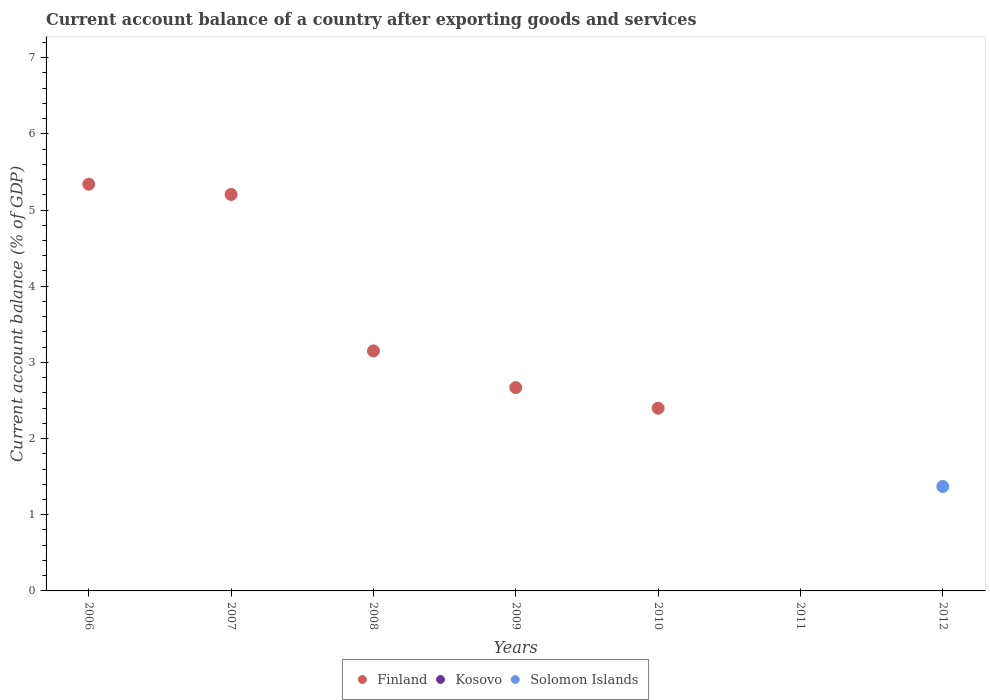Is the number of dotlines equal to the number of legend labels?
Your response must be concise. No. What is the account balance in Finland in 2008?
Your answer should be compact. 3.15. Across all years, what is the maximum account balance in Finland?
Your response must be concise. 5.34. What is the total account balance in Kosovo in the graph?
Offer a terse response. 0. What is the difference between the account balance in Finland in 2008 and that in 2010?
Ensure brevity in your answer.  0.75. What is the average account balance in Solomon Islands per year?
Your response must be concise. 0.2. In how many years, is the account balance in Finland greater than 2 %?
Ensure brevity in your answer.  5. What is the ratio of the account balance in Finland in 2006 to that in 2008?
Offer a terse response. 1.69. What is the difference between the highest and the second highest account balance in Finland?
Ensure brevity in your answer.  0.13. What is the difference between the highest and the lowest account balance in Solomon Islands?
Offer a very short reply. 1.37. In how many years, is the account balance in Kosovo greater than the average account balance in Kosovo taken over all years?
Provide a short and direct response. 0. Is it the case that in every year, the sum of the account balance in Kosovo and account balance in Finland  is greater than the account balance in Solomon Islands?
Make the answer very short. No. Is the account balance in Kosovo strictly greater than the account balance in Solomon Islands over the years?
Offer a terse response. No. Is the account balance in Solomon Islands strictly less than the account balance in Finland over the years?
Your answer should be compact. No. How many years are there in the graph?
Keep it short and to the point. 7. Where does the legend appear in the graph?
Ensure brevity in your answer.  Bottom center. How many legend labels are there?
Ensure brevity in your answer.  3. What is the title of the graph?
Keep it short and to the point. Current account balance of a country after exporting goods and services. Does "Mexico" appear as one of the legend labels in the graph?
Your answer should be very brief. No. What is the label or title of the X-axis?
Offer a very short reply. Years. What is the label or title of the Y-axis?
Your answer should be compact. Current account balance (% of GDP). What is the Current account balance (% of GDP) in Finland in 2006?
Keep it short and to the point. 5.34. What is the Current account balance (% of GDP) in Kosovo in 2006?
Offer a very short reply. 0. What is the Current account balance (% of GDP) in Solomon Islands in 2006?
Your answer should be very brief. 0. What is the Current account balance (% of GDP) in Finland in 2007?
Provide a succinct answer. 5.2. What is the Current account balance (% of GDP) in Solomon Islands in 2007?
Your response must be concise. 0. What is the Current account balance (% of GDP) of Finland in 2008?
Your answer should be compact. 3.15. What is the Current account balance (% of GDP) of Solomon Islands in 2008?
Offer a terse response. 0. What is the Current account balance (% of GDP) of Finland in 2009?
Offer a very short reply. 2.67. What is the Current account balance (% of GDP) of Kosovo in 2009?
Ensure brevity in your answer.  0. What is the Current account balance (% of GDP) of Finland in 2010?
Ensure brevity in your answer.  2.4. What is the Current account balance (% of GDP) in Kosovo in 2010?
Give a very brief answer. 0. What is the Current account balance (% of GDP) in Solomon Islands in 2010?
Offer a very short reply. 0. What is the Current account balance (% of GDP) in Solomon Islands in 2011?
Offer a terse response. 0. What is the Current account balance (% of GDP) in Finland in 2012?
Make the answer very short. 0. What is the Current account balance (% of GDP) of Kosovo in 2012?
Offer a terse response. 0. What is the Current account balance (% of GDP) of Solomon Islands in 2012?
Make the answer very short. 1.37. Across all years, what is the maximum Current account balance (% of GDP) of Finland?
Offer a very short reply. 5.34. Across all years, what is the maximum Current account balance (% of GDP) of Solomon Islands?
Make the answer very short. 1.37. What is the total Current account balance (% of GDP) in Finland in the graph?
Make the answer very short. 18.76. What is the total Current account balance (% of GDP) in Solomon Islands in the graph?
Your response must be concise. 1.37. What is the difference between the Current account balance (% of GDP) in Finland in 2006 and that in 2007?
Your response must be concise. 0.13. What is the difference between the Current account balance (% of GDP) of Finland in 2006 and that in 2008?
Offer a very short reply. 2.19. What is the difference between the Current account balance (% of GDP) in Finland in 2006 and that in 2009?
Offer a very short reply. 2.67. What is the difference between the Current account balance (% of GDP) in Finland in 2006 and that in 2010?
Give a very brief answer. 2.94. What is the difference between the Current account balance (% of GDP) of Finland in 2007 and that in 2008?
Provide a succinct answer. 2.05. What is the difference between the Current account balance (% of GDP) of Finland in 2007 and that in 2009?
Give a very brief answer. 2.54. What is the difference between the Current account balance (% of GDP) in Finland in 2007 and that in 2010?
Your response must be concise. 2.81. What is the difference between the Current account balance (% of GDP) in Finland in 2008 and that in 2009?
Keep it short and to the point. 0.48. What is the difference between the Current account balance (% of GDP) of Finland in 2008 and that in 2010?
Provide a succinct answer. 0.75. What is the difference between the Current account balance (% of GDP) in Finland in 2009 and that in 2010?
Your answer should be very brief. 0.27. What is the difference between the Current account balance (% of GDP) of Finland in 2006 and the Current account balance (% of GDP) of Solomon Islands in 2012?
Your answer should be very brief. 3.97. What is the difference between the Current account balance (% of GDP) in Finland in 2007 and the Current account balance (% of GDP) in Solomon Islands in 2012?
Your answer should be very brief. 3.83. What is the difference between the Current account balance (% of GDP) in Finland in 2008 and the Current account balance (% of GDP) in Solomon Islands in 2012?
Your answer should be very brief. 1.78. What is the difference between the Current account balance (% of GDP) in Finland in 2009 and the Current account balance (% of GDP) in Solomon Islands in 2012?
Make the answer very short. 1.3. What is the difference between the Current account balance (% of GDP) of Finland in 2010 and the Current account balance (% of GDP) of Solomon Islands in 2012?
Give a very brief answer. 1.03. What is the average Current account balance (% of GDP) of Finland per year?
Provide a short and direct response. 2.68. What is the average Current account balance (% of GDP) of Solomon Islands per year?
Keep it short and to the point. 0.2. What is the ratio of the Current account balance (% of GDP) of Finland in 2006 to that in 2007?
Keep it short and to the point. 1.03. What is the ratio of the Current account balance (% of GDP) of Finland in 2006 to that in 2008?
Your response must be concise. 1.69. What is the ratio of the Current account balance (% of GDP) of Finland in 2006 to that in 2009?
Give a very brief answer. 2. What is the ratio of the Current account balance (% of GDP) in Finland in 2006 to that in 2010?
Offer a terse response. 2.23. What is the ratio of the Current account balance (% of GDP) of Finland in 2007 to that in 2008?
Ensure brevity in your answer.  1.65. What is the ratio of the Current account balance (% of GDP) in Finland in 2007 to that in 2009?
Give a very brief answer. 1.95. What is the ratio of the Current account balance (% of GDP) in Finland in 2007 to that in 2010?
Offer a terse response. 2.17. What is the ratio of the Current account balance (% of GDP) in Finland in 2008 to that in 2009?
Your answer should be compact. 1.18. What is the ratio of the Current account balance (% of GDP) in Finland in 2008 to that in 2010?
Your answer should be very brief. 1.31. What is the ratio of the Current account balance (% of GDP) in Finland in 2009 to that in 2010?
Give a very brief answer. 1.11. What is the difference between the highest and the second highest Current account balance (% of GDP) of Finland?
Provide a succinct answer. 0.13. What is the difference between the highest and the lowest Current account balance (% of GDP) of Finland?
Keep it short and to the point. 5.34. What is the difference between the highest and the lowest Current account balance (% of GDP) of Solomon Islands?
Keep it short and to the point. 1.37. 